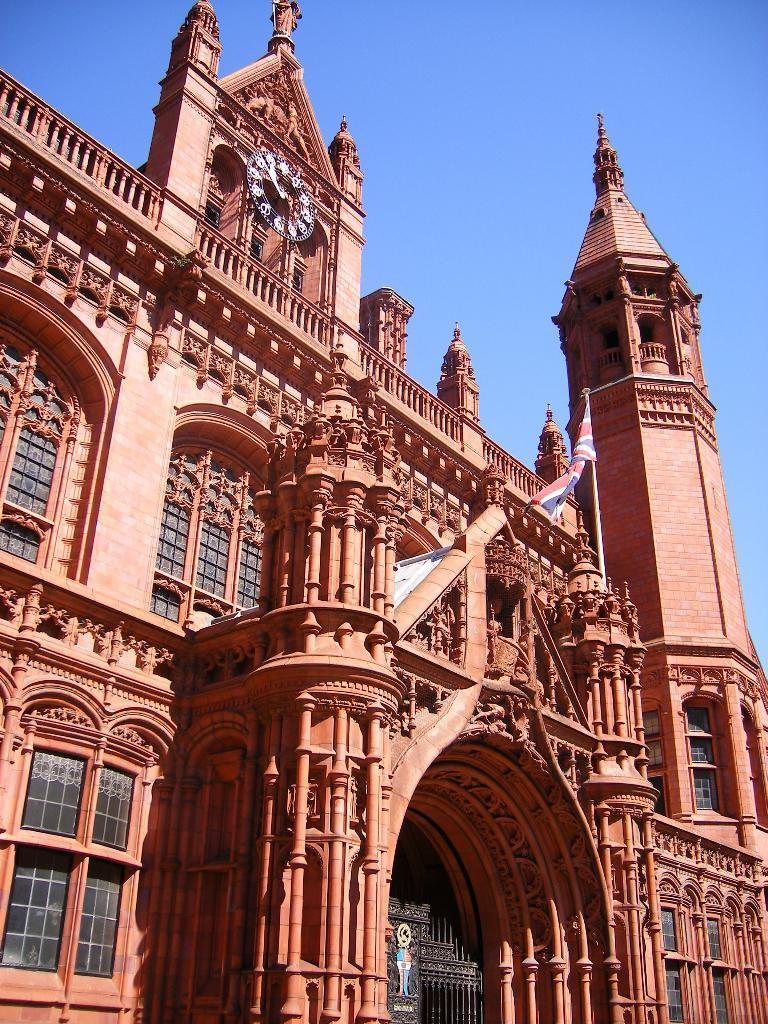What type of structure is present in the image? There is a building in the image. What features can be seen on the building? There is a clock and a flag on the building. What type of openings are present on the building? The building has windows. What can be seen in the background of the image? The sky is visible in the background of the image. Can you see any ghosts or sheep in the image? No, there are no ghosts or sheep present in the image. 